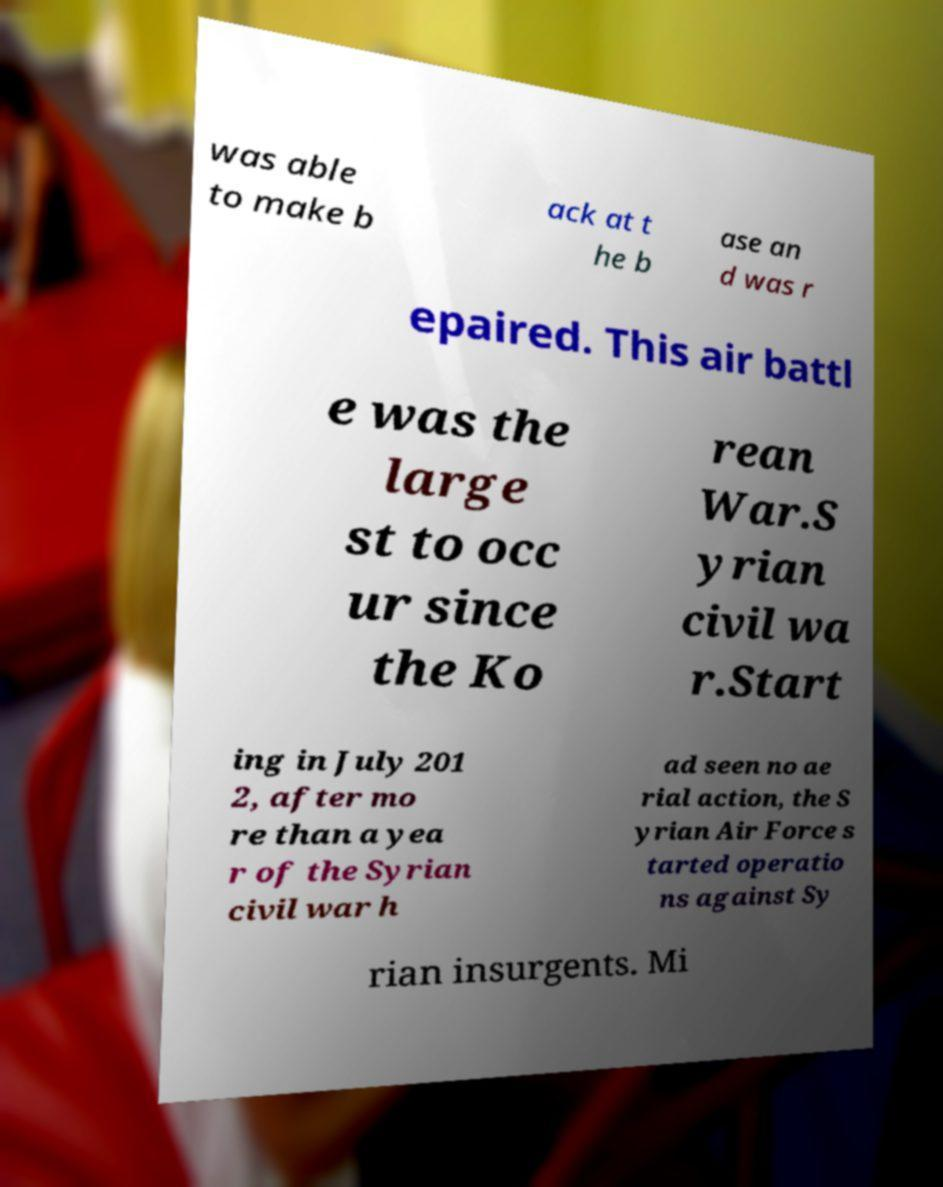Could you extract and type out the text from this image? was able to make b ack at t he b ase an d was r epaired. This air battl e was the large st to occ ur since the Ko rean War.S yrian civil wa r.Start ing in July 201 2, after mo re than a yea r of the Syrian civil war h ad seen no ae rial action, the S yrian Air Force s tarted operatio ns against Sy rian insurgents. Mi 